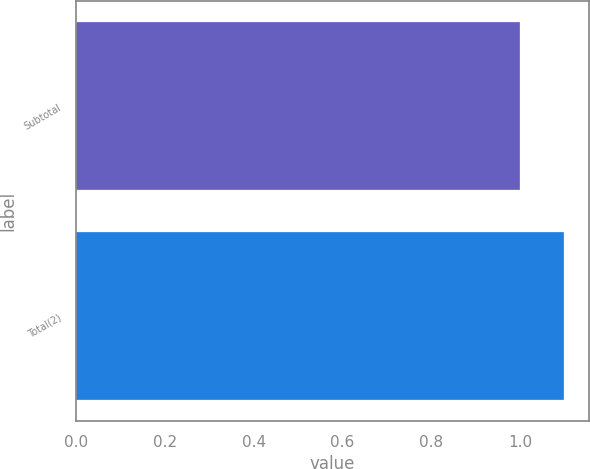Convert chart to OTSL. <chart><loc_0><loc_0><loc_500><loc_500><bar_chart><fcel>Subtotal<fcel>Total(2)<nl><fcel>1<fcel>1.1<nl></chart> 